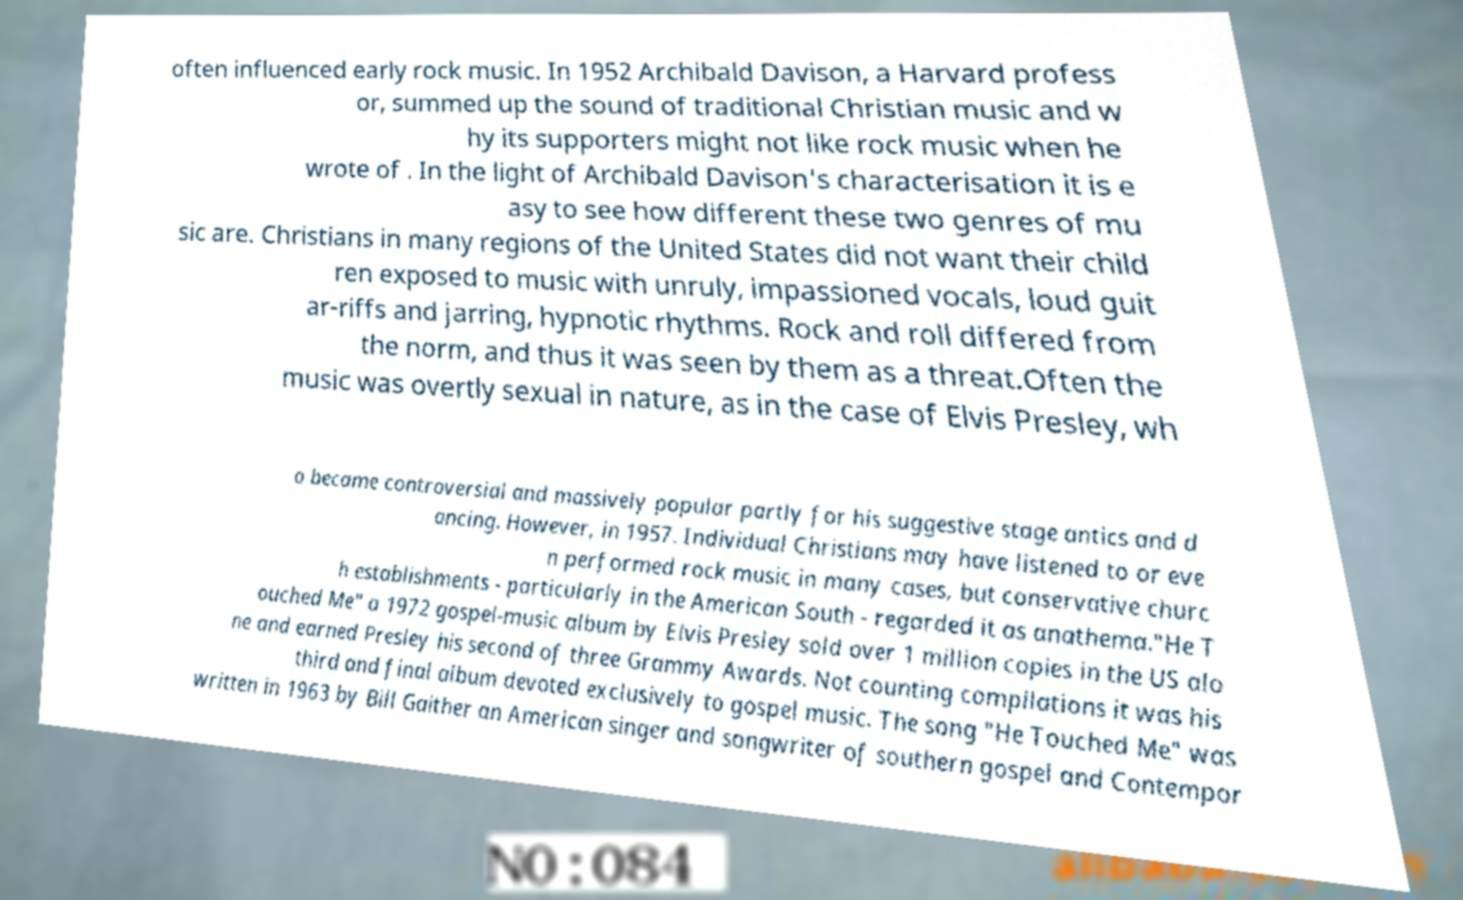There's text embedded in this image that I need extracted. Can you transcribe it verbatim? often influenced early rock music. In 1952 Archibald Davison, a Harvard profess or, summed up the sound of traditional Christian music and w hy its supporters might not like rock music when he wrote of . In the light of Archibald Davison's characterisation it is e asy to see how different these two genres of mu sic are. Christians in many regions of the United States did not want their child ren exposed to music with unruly, impassioned vocals, loud guit ar-riffs and jarring, hypnotic rhythms. Rock and roll differed from the norm, and thus it was seen by them as a threat.Often the music was overtly sexual in nature, as in the case of Elvis Presley, wh o became controversial and massively popular partly for his suggestive stage antics and d ancing. However, in 1957. Individual Christians may have listened to or eve n performed rock music in many cases, but conservative churc h establishments - particularly in the American South - regarded it as anathema."He T ouched Me" a 1972 gospel-music album by Elvis Presley sold over 1 million copies in the US alo ne and earned Presley his second of three Grammy Awards. Not counting compilations it was his third and final album devoted exclusively to gospel music. The song "He Touched Me" was written in 1963 by Bill Gaither an American singer and songwriter of southern gospel and Contempor 